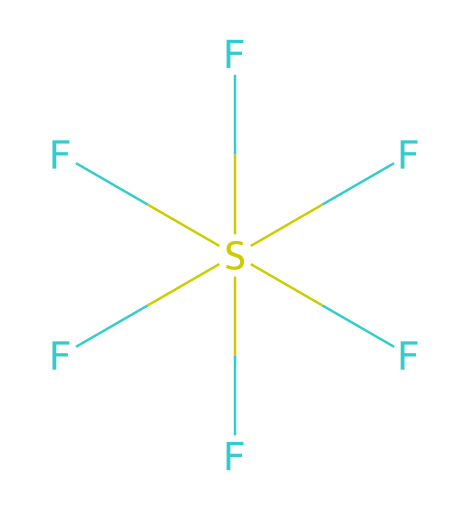What is the name of this compound? The SMILES representation indicates that this compound is SF6, which is the chemical formula for sulfur hexafluoride.
Answer: sulfur hexafluoride How many fluorine atoms are present? The structural formula shows six fluorine (F) atoms surrounding one sulfur (S) atom.
Answer: six What type of bond is present between sulfur and fluorine? In sulfur hexafluoride, each sulfur-fluorine connection is a single covalent bond, as indicated by the absence of double or triple bonds in the structure.
Answer: single covalent What is the molecular geometry of sulfur hexafluoride? The arrangement of six fluorine atoms around the central sulfur atom leads to an octahedral molecular geometry, characteristic of sulfur hexafluoride.
Answer: octahedral Why is sulfur hexafluoride used in high-voltage circuit breakers? The fluorine atoms create a highly stable and non-reactive gas, which effectively insulates and extinguishes arcs in high-voltage applications.
Answer: stability Which element has the highest electronegativity in this compound? Fluorine is the most electronegative element in this compound, significantly more so than sulfur, which influences the compound's properties.
Answer: fluorine What is the oxidation state of sulfur in this compound? In SF6, sulfur has an oxidation state of +6, as each fluorine atom contributes -1, and the overall charge is neutral, leading to +6 for sulfur.
Answer: +6 